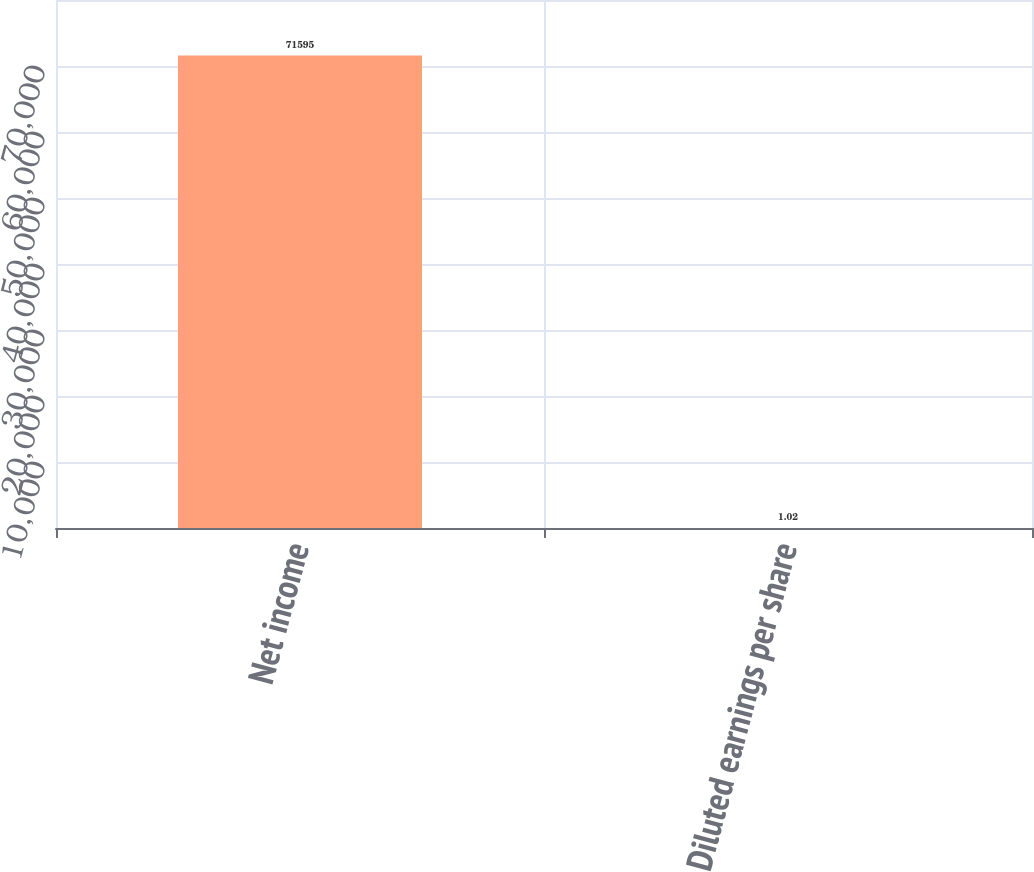<chart> <loc_0><loc_0><loc_500><loc_500><bar_chart><fcel>Net income<fcel>Diluted earnings per share<nl><fcel>71595<fcel>1.02<nl></chart> 